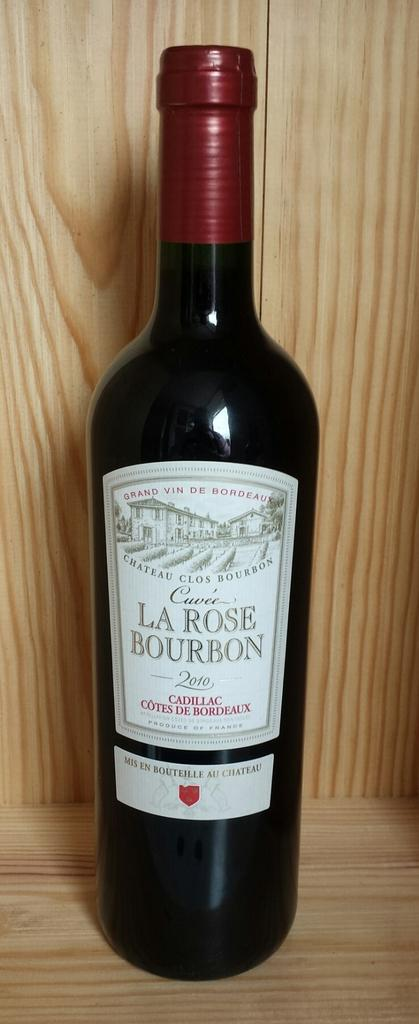<image>
Offer a succinct explanation of the picture presented. bottle of 2010 la rose bourbon on a wooden shelf 